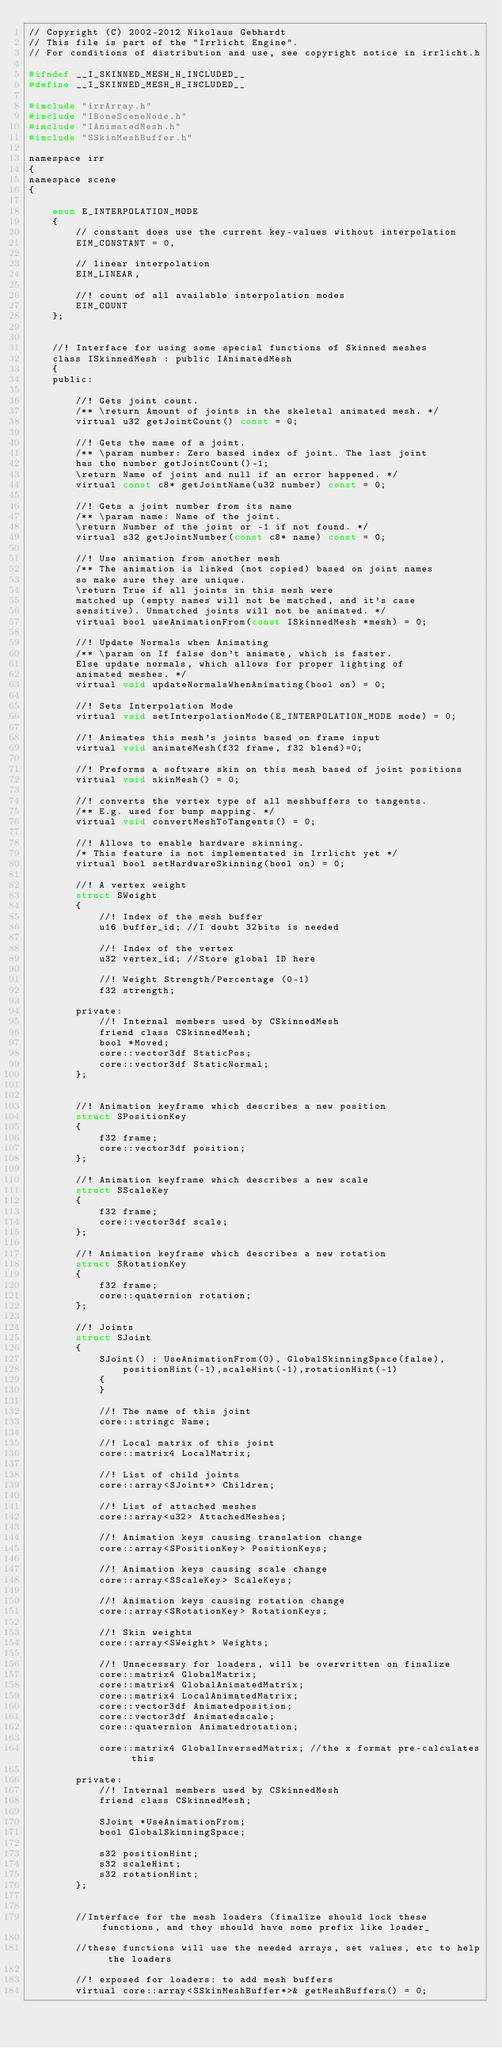<code> <loc_0><loc_0><loc_500><loc_500><_C_>// Copyright (C) 2002-2012 Nikolaus Gebhardt
// This file is part of the "Irrlicht Engine".
// For conditions of distribution and use, see copyright notice in irrlicht.h

#ifndef __I_SKINNED_MESH_H_INCLUDED__
#define __I_SKINNED_MESH_H_INCLUDED__

#include "irrArray.h"
#include "IBoneSceneNode.h"
#include "IAnimatedMesh.h"
#include "SSkinMeshBuffer.h"

namespace irr
{
namespace scene
{

	enum E_INTERPOLATION_MODE
	{
		// constant does use the current key-values without interpolation
		EIM_CONSTANT = 0,

		// linear interpolation
		EIM_LINEAR,

		//! count of all available interpolation modes
		EIM_COUNT
	};


	//! Interface for using some special functions of Skinned meshes
	class ISkinnedMesh : public IAnimatedMesh
	{
	public:

		//! Gets joint count.
		/** \return Amount of joints in the skeletal animated mesh. */
		virtual u32 getJointCount() const = 0;

		//! Gets the name of a joint.
		/** \param number: Zero based index of joint. The last joint
		has the number getJointCount()-1;
		\return Name of joint and null if an error happened. */
		virtual const c8* getJointName(u32 number) const = 0;

		//! Gets a joint number from its name
		/** \param name: Name of the joint.
		\return Number of the joint or -1 if not found. */
		virtual s32 getJointNumber(const c8* name) const = 0;

		//! Use animation from another mesh
		/** The animation is linked (not copied) based on joint names
		so make sure they are unique.
		\return True if all joints in this mesh were
		matched up (empty names will not be matched, and it's case
		sensitive). Unmatched joints will not be animated. */
		virtual bool useAnimationFrom(const ISkinnedMesh *mesh) = 0;

		//! Update Normals when Animating
		/** \param on If false don't animate, which is faster.
		Else update normals, which allows for proper lighting of
		animated meshes. */
		virtual void updateNormalsWhenAnimating(bool on) = 0;

		//! Sets Interpolation Mode
		virtual void setInterpolationMode(E_INTERPOLATION_MODE mode) = 0;

		//! Animates this mesh's joints based on frame input
		virtual void animateMesh(f32 frame, f32 blend)=0;

		//! Preforms a software skin on this mesh based of joint positions
		virtual void skinMesh() = 0;

		//! converts the vertex type of all meshbuffers to tangents.
		/** E.g. used for bump mapping. */
		virtual void convertMeshToTangents() = 0;

		//! Allows to enable hardware skinning.
		/* This feature is not implementated in Irrlicht yet */
		virtual bool setHardwareSkinning(bool on) = 0;

		//! A vertex weight
		struct SWeight
		{
			//! Index of the mesh buffer
			u16 buffer_id; //I doubt 32bits is needed

			//! Index of the vertex
			u32 vertex_id; //Store global ID here

			//! Weight Strength/Percentage (0-1)
			f32 strength;

		private:
			//! Internal members used by CSkinnedMesh
			friend class CSkinnedMesh;
			bool *Moved;
			core::vector3df StaticPos;
			core::vector3df StaticNormal;
		};


		//! Animation keyframe which describes a new position
		struct SPositionKey
		{
			f32 frame;
			core::vector3df position;
		};

		//! Animation keyframe which describes a new scale
		struct SScaleKey
		{
			f32 frame;
			core::vector3df scale;
		};

		//! Animation keyframe which describes a new rotation
		struct SRotationKey
		{
			f32 frame;
			core::quaternion rotation;
		};

		//! Joints
		struct SJoint
		{
			SJoint() : UseAnimationFrom(0), GlobalSkinningSpace(false),
				positionHint(-1),scaleHint(-1),rotationHint(-1)
			{
			}

			//! The name of this joint
			core::stringc Name;

			//! Local matrix of this joint
			core::matrix4 LocalMatrix;

			//! List of child joints
			core::array<SJoint*> Children;

			//! List of attached meshes
			core::array<u32> AttachedMeshes;

			//! Animation keys causing translation change
			core::array<SPositionKey> PositionKeys;

			//! Animation keys causing scale change
			core::array<SScaleKey> ScaleKeys;

			//! Animation keys causing rotation change
			core::array<SRotationKey> RotationKeys;

			//! Skin weights
			core::array<SWeight> Weights;

			//! Unnecessary for loaders, will be overwritten on finalize
			core::matrix4 GlobalMatrix;
			core::matrix4 GlobalAnimatedMatrix;
			core::matrix4 LocalAnimatedMatrix;
			core::vector3df Animatedposition;
			core::vector3df Animatedscale;
			core::quaternion Animatedrotation;

			core::matrix4 GlobalInversedMatrix; //the x format pre-calculates this

		private:
			//! Internal members used by CSkinnedMesh
			friend class CSkinnedMesh;

			SJoint *UseAnimationFrom;
			bool GlobalSkinningSpace;

			s32 positionHint;
			s32 scaleHint;
			s32 rotationHint;
		};


		//Interface for the mesh loaders (finalize should lock these functions, and they should have some prefix like loader_

		//these functions will use the needed arrays, set values, etc to help the loaders

		//! exposed for loaders: to add mesh buffers
		virtual core::array<SSkinMeshBuffer*>& getMeshBuffers() = 0;
</code> 